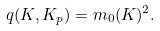Convert formula to latex. <formula><loc_0><loc_0><loc_500><loc_500>q ( K , K _ { p } ) = m _ { 0 } ( K ) ^ { 2 } .</formula> 